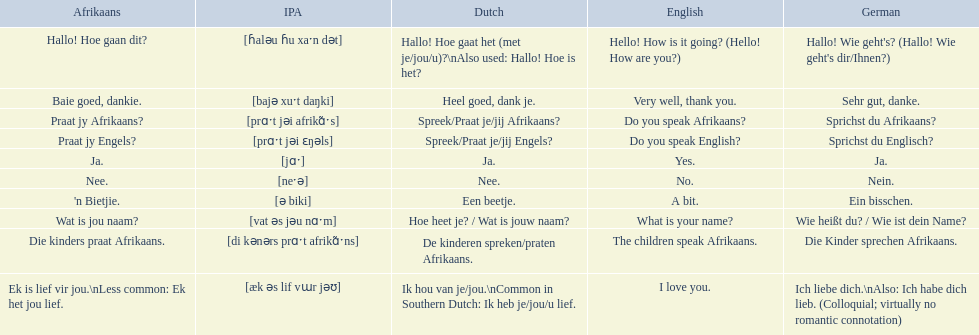What is the english translation of 'n bietjie? A bit. 